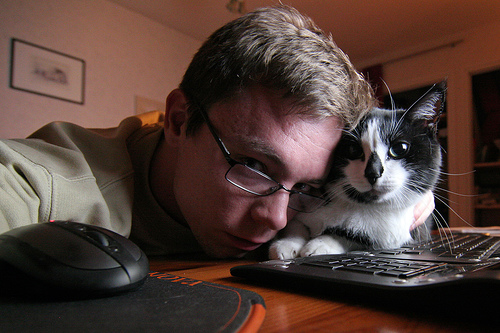<image>
Is the man under the cat? No. The man is not positioned under the cat. The vertical relationship between these objects is different. Is there a man behind the cat? No. The man is not behind the cat. From this viewpoint, the man appears to be positioned elsewhere in the scene. Is there a man on the cat? Yes. Looking at the image, I can see the man is positioned on top of the cat, with the cat providing support. 